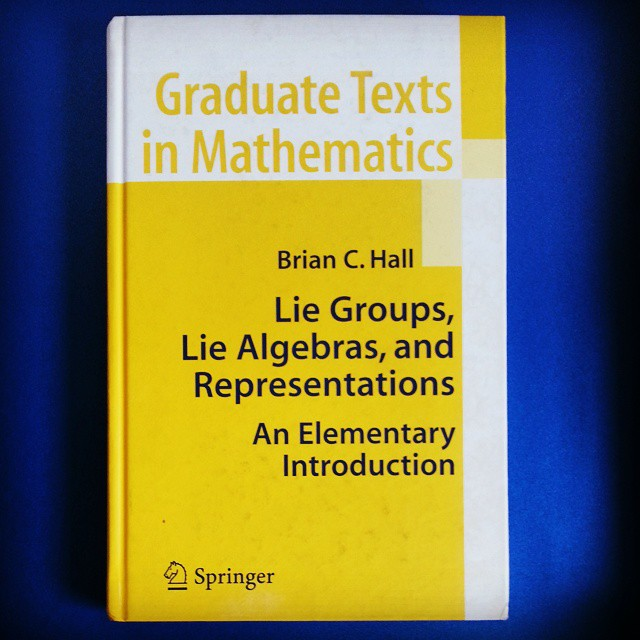What mathematical concepts might be covered in a book with a title like this? Based on the title 'Lie Groups, Lie Algebras, and Representations,' the book likely delves into advanced mathematical structures that play a crucial role in various domains of mathematics and physics. Specifically, Lie groups are continuous groups pivotal in understanding symmetries, with applications ranging from geometry to the conservation laws in physics. Lie algebras, closely associated with Lie groups, offer an algebraic framework to study these symmetries more deeply. Representations provide a means to translate these abstract structures into concrete linear transformations of vector spaces, facilitating practical computations and extensive applications in theoretical physics, quantum mechanics, and beyond. Considering it is noted as 'An Elementary Introduction,' the book aims to build a strong foundational knowledge for students or researchers new to these sophisticated topics, likely at the graduate level or early research stage. 